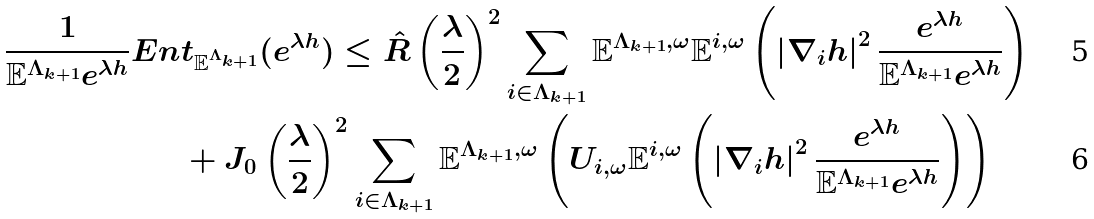Convert formula to latex. <formula><loc_0><loc_0><loc_500><loc_500>\frac { 1 } { \mathbb { E } ^ { \Lambda _ { k + 1 } } e ^ { \lambda h } } E n & t _ { \mathbb { E } ^ { \Lambda _ { k + 1 } } } ( e ^ { \lambda h } ) \leq \hat { R } \left ( \frac { \lambda } { 2 } \right ) ^ { 2 } \sum _ { i \in \Lambda _ { k + 1 } } \mathbb { E } ^ { \Lambda _ { k + 1 } , \omega } \mathbb { E } ^ { i , \omega } \left ( \left | \nabla _ { i } h \right | ^ { 2 } \frac { e ^ { \lambda h } } { \mathbb { E } ^ { \Lambda _ { k + 1 } } e ^ { \lambda h } } \right ) \\ & + J _ { 0 } \left ( \frac { \lambda } { 2 } \right ) ^ { 2 } \sum _ { i \in \Lambda _ { k + 1 } } \mathbb { E } ^ { \Lambda _ { k + 1 } , \omega } \left ( U _ { i , \omega } \mathbb { E } ^ { i , \omega } \left ( \left | \nabla _ { i } h \right | ^ { 2 } \frac { e ^ { \lambda h } } { \mathbb { E } ^ { \Lambda _ { k + 1 } } e ^ { \lambda h } } \right ) \right )</formula> 